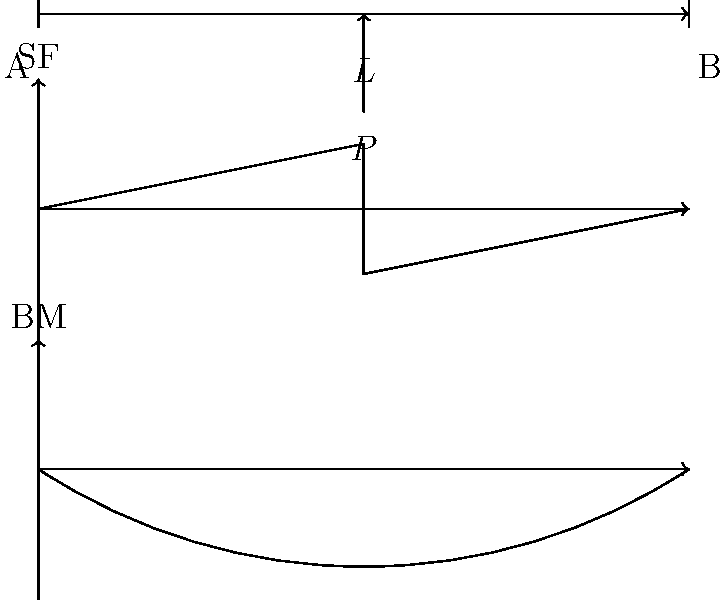In a classic rock concert setup, a simply supported bridge stage is used to elevate the drummer. The stage can be modeled as a beam of length $L$ with a concentrated load $P$ at its midpoint. Sketch the shear force (SF) and bending moment (BM) diagrams for this setup. How does the maximum bending moment relate to the load $P$ and length $L$? Let's approach this step-by-step, relating it to the setup of a rock concert stage:

1) First, we need to determine the reaction forces at the supports (A and B):
   Due to symmetry, $R_A = R_B = P/2$

2) Shear Force Diagram:
   - From A to the load: SF = $P/2$
   - At the load: SF jumps from $P/2$ to $-P/2$
   - From the load to B: SF = $-P/2$

3) Bending Moment Diagram:
   - BM increases linearly from 0 at A to a maximum at the midpoint
   - Then decreases linearly back to 0 at B

4) To find the maximum bending moment:
   - It occurs at the midpoint (where the load is applied)
   - $M_{max} = R_A \cdot (L/2) = (P/2) \cdot (L/2) = PL/4$

5) The shape of the BM diagram is parabolic, much like the arc of a spotlight beam in a concert.

Therefore, the maximum bending moment in the stage beam is directly proportional to both the weight of the drum set ($P$) and the length of the stage ($L$).
Answer: $M_{max} = PL/4$ 